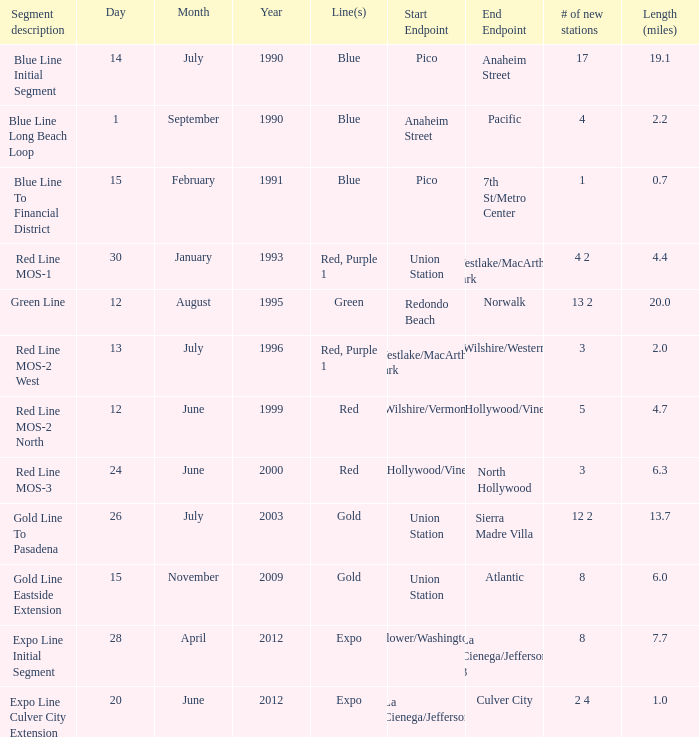What is the length in miles from westlake/macarthur park to wilshire/western endpoints? 2.0. 